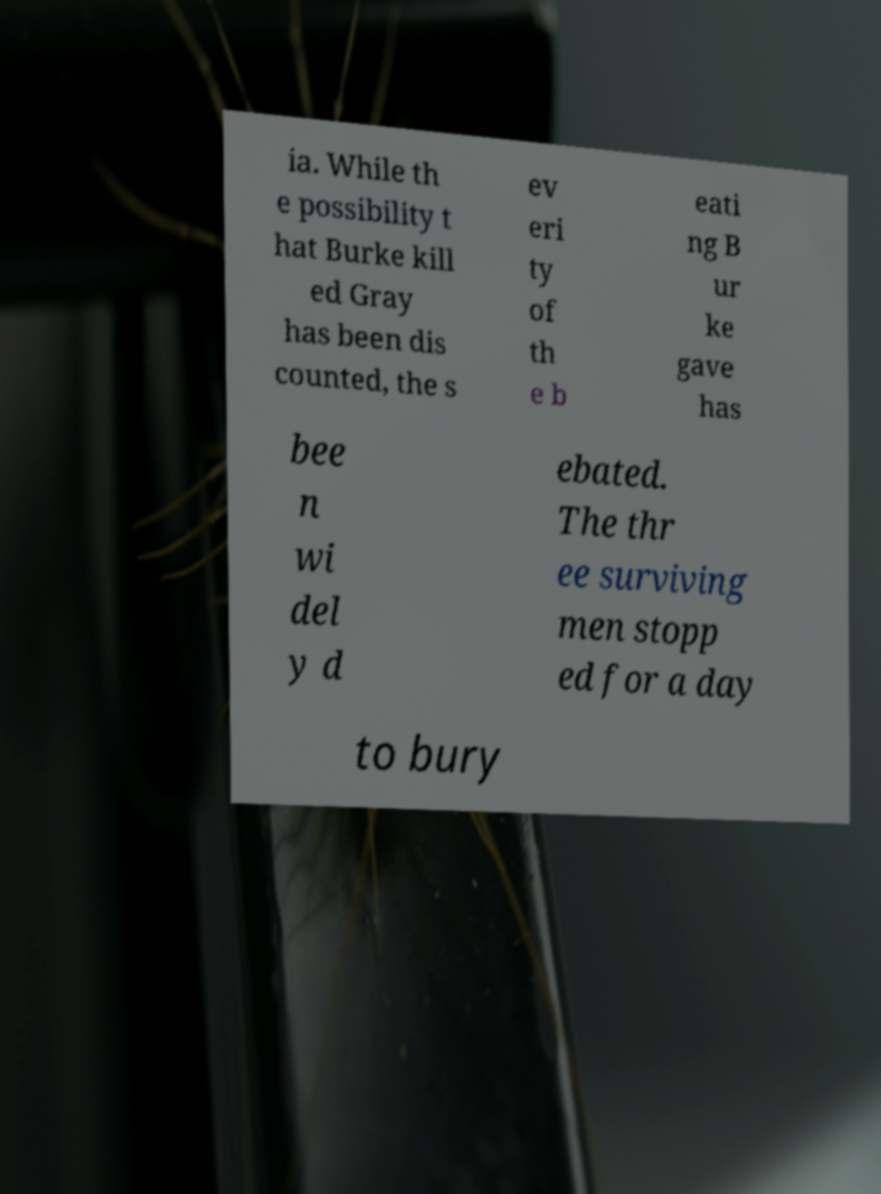What messages or text are displayed in this image? I need them in a readable, typed format. ia. While th e possibility t hat Burke kill ed Gray has been dis counted, the s ev eri ty of th e b eati ng B ur ke gave has bee n wi del y d ebated. The thr ee surviving men stopp ed for a day to bury 